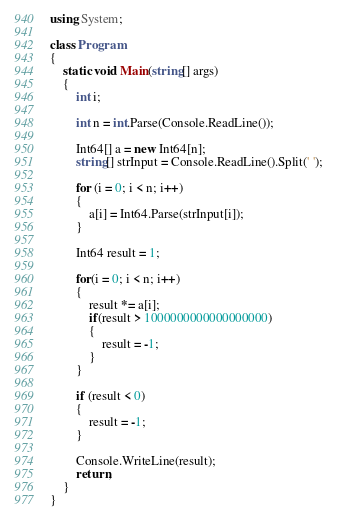Convert code to text. <code><loc_0><loc_0><loc_500><loc_500><_C#_>using System;

class Program
{
	static void Main(string[] args)
	{
		int i;

		int n = int.Parse(Console.ReadLine());

		Int64[] a = new Int64[n];
		string[] strInput = Console.ReadLine().Split(' ');

		for (i = 0; i < n; i++)
		{
			a[i] = Int64.Parse(strInput[i]);
		}

		Int64 result = 1;

		for(i = 0; i < n; i++)
		{
			result *= a[i];
			if(result > 1000000000000000000)
			{
				result = -1;
			}
		}

		if (result < 0)
		{
			result = -1;
		}

		Console.WriteLine(result);
		return;
	}
}</code> 